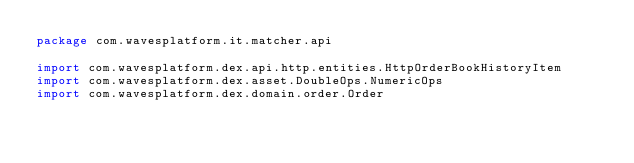<code> <loc_0><loc_0><loc_500><loc_500><_Scala_>package com.wavesplatform.it.matcher.api

import com.wavesplatform.dex.api.http.entities.HttpOrderBookHistoryItem
import com.wavesplatform.dex.asset.DoubleOps.NumericOps
import com.wavesplatform.dex.domain.order.Order</code> 